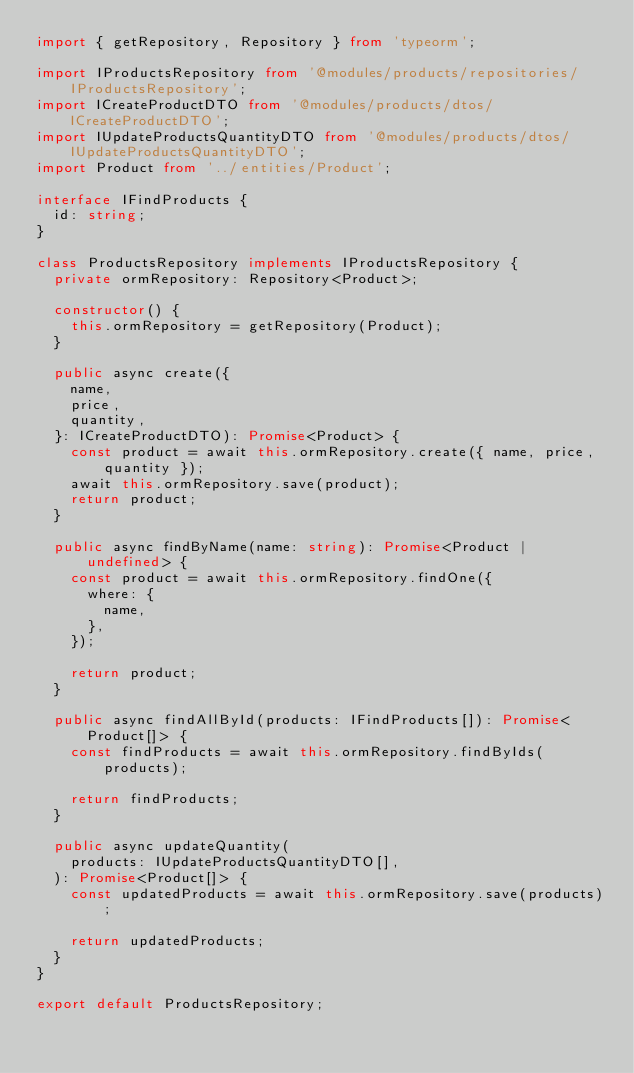<code> <loc_0><loc_0><loc_500><loc_500><_TypeScript_>import { getRepository, Repository } from 'typeorm';

import IProductsRepository from '@modules/products/repositories/IProductsRepository';
import ICreateProductDTO from '@modules/products/dtos/ICreateProductDTO';
import IUpdateProductsQuantityDTO from '@modules/products/dtos/IUpdateProductsQuantityDTO';
import Product from '../entities/Product';

interface IFindProducts {
  id: string;
}

class ProductsRepository implements IProductsRepository {
  private ormRepository: Repository<Product>;

  constructor() {
    this.ormRepository = getRepository(Product);
  }

  public async create({
    name,
    price,
    quantity,
  }: ICreateProductDTO): Promise<Product> {
    const product = await this.ormRepository.create({ name, price, quantity });
    await this.ormRepository.save(product);
    return product;
  }

  public async findByName(name: string): Promise<Product | undefined> {
    const product = await this.ormRepository.findOne({
      where: {
        name,
      },
    });

    return product;
  }

  public async findAllById(products: IFindProducts[]): Promise<Product[]> {
    const findProducts = await this.ormRepository.findByIds(products);

    return findProducts;
  }

  public async updateQuantity(
    products: IUpdateProductsQuantityDTO[],
  ): Promise<Product[]> {
    const updatedProducts = await this.ormRepository.save(products);

    return updatedProducts;
  }
}

export default ProductsRepository;
</code> 